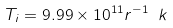<formula> <loc_0><loc_0><loc_500><loc_500>T _ { i } = 9 . 9 9 \times 1 0 ^ { 1 1 } r ^ { - 1 } \ k</formula> 